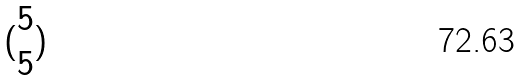<formula> <loc_0><loc_0><loc_500><loc_500>( \begin{matrix} 5 \\ 5 \end{matrix} )</formula> 